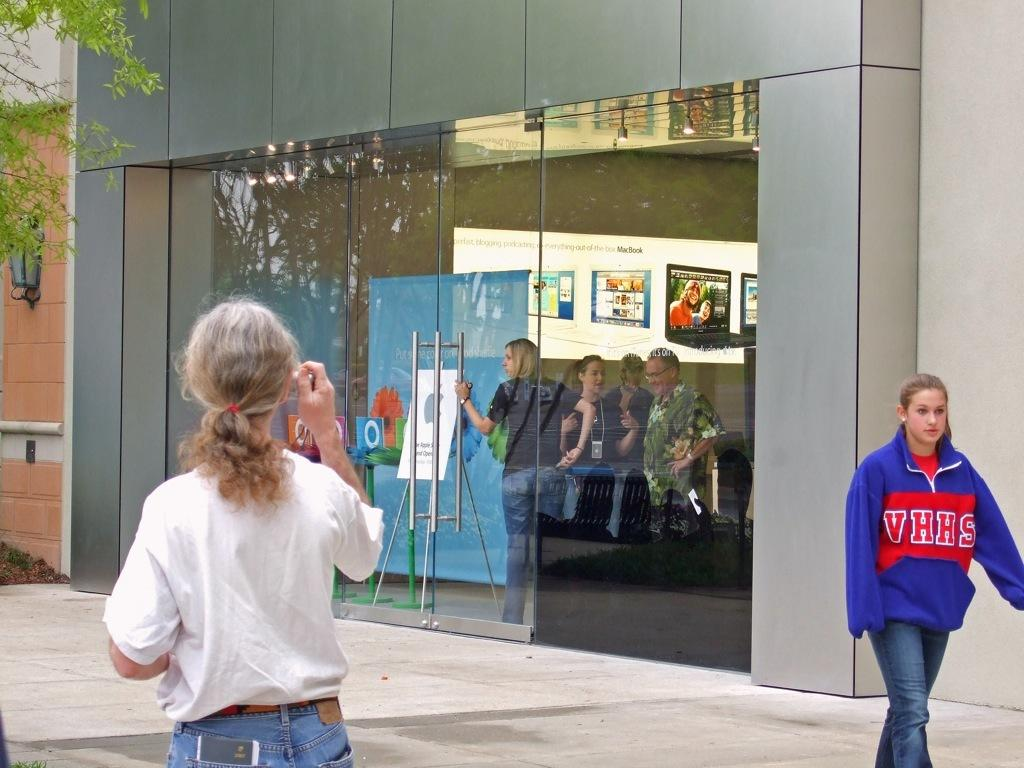Provide a one-sentence caption for the provided image. The blue hoodie has the letters VHHS on it. 